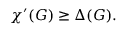Convert formula to latex. <formula><loc_0><loc_0><loc_500><loc_500>\chi ^ { \prime } ( G ) \geq \Delta ( G ) .</formula> 